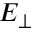<formula> <loc_0><loc_0><loc_500><loc_500>E _ { \perp }</formula> 